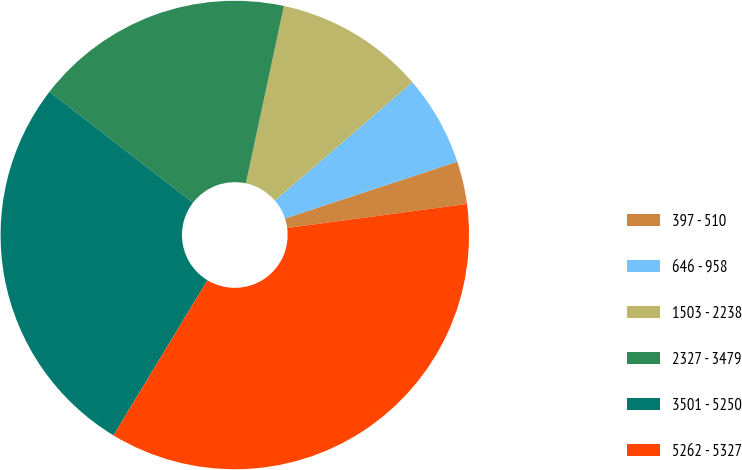Convert chart to OTSL. <chart><loc_0><loc_0><loc_500><loc_500><pie_chart><fcel>397 - 510<fcel>646 - 958<fcel>1503 - 2238<fcel>2327 - 3479<fcel>3501 - 5250<fcel>5262 - 5327<nl><fcel>2.95%<fcel>6.24%<fcel>10.33%<fcel>17.89%<fcel>26.81%<fcel>35.78%<nl></chart> 